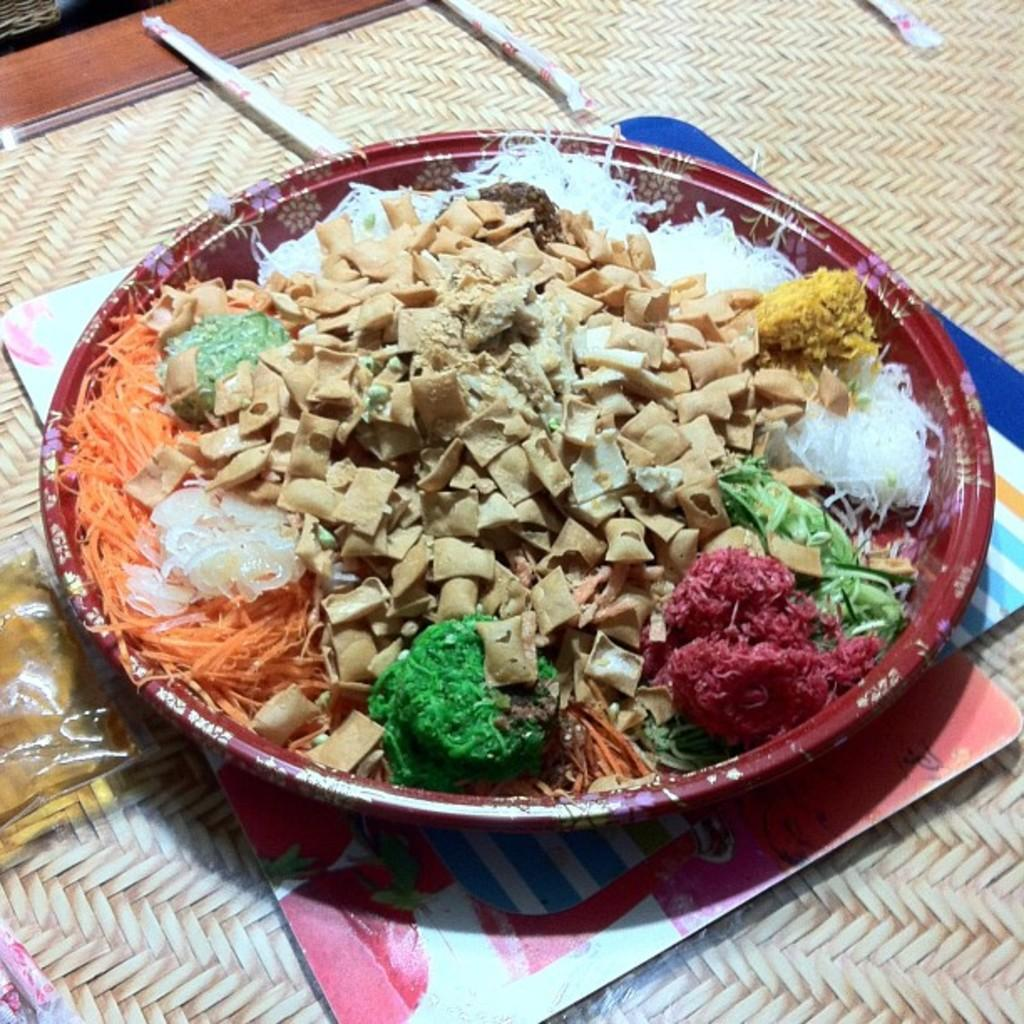What is on the plate that is visible in the image? The plate contains chips and carrot slices, as well as other food. Where is the plate located in the image? The plate is placed on a mat. What else can be seen on the left side of the image? There is a packet on the left side of the image. What color is the sun in the image? There is no sun present in the image. Are there any trousers visible in the image? There is no mention of trousers in the provided facts, and therefore no such item can be observed in the image. 